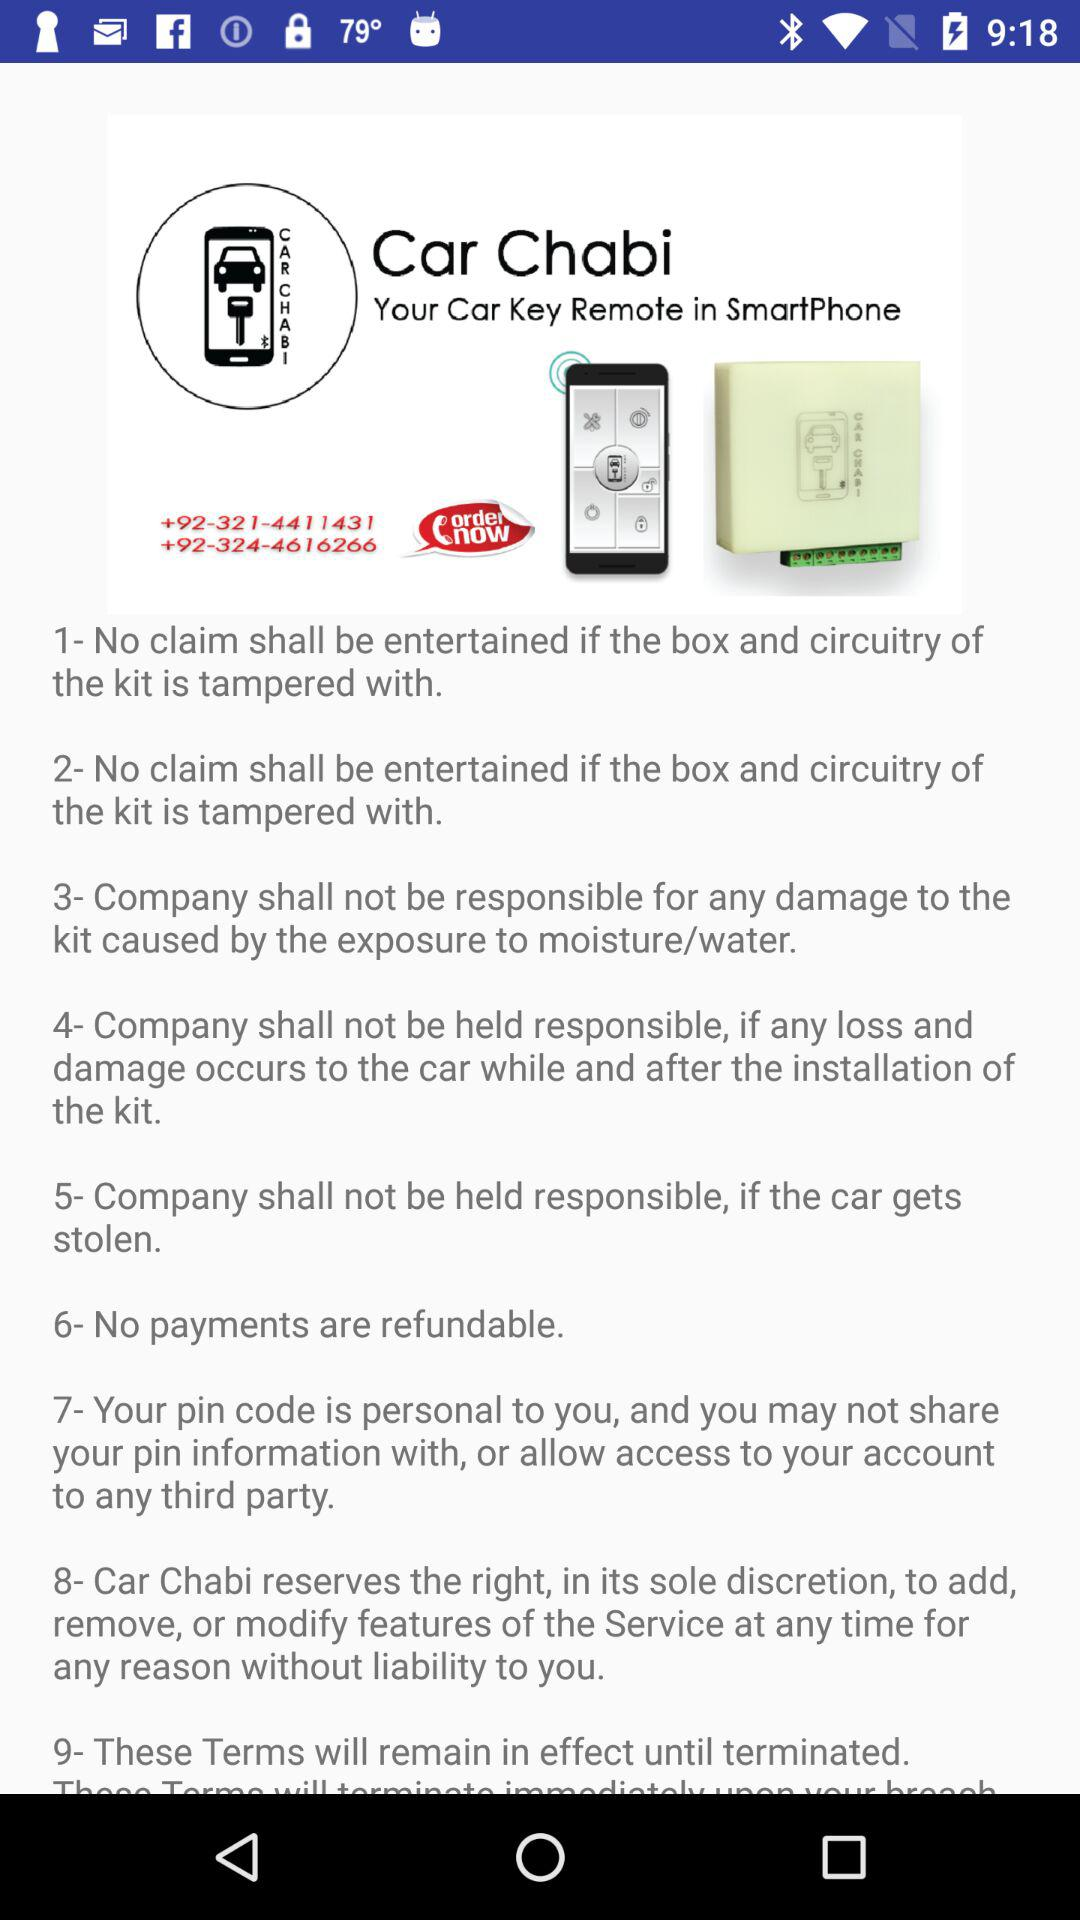How many terms are there in the terms and conditions?
Answer the question using a single word or phrase. 9 